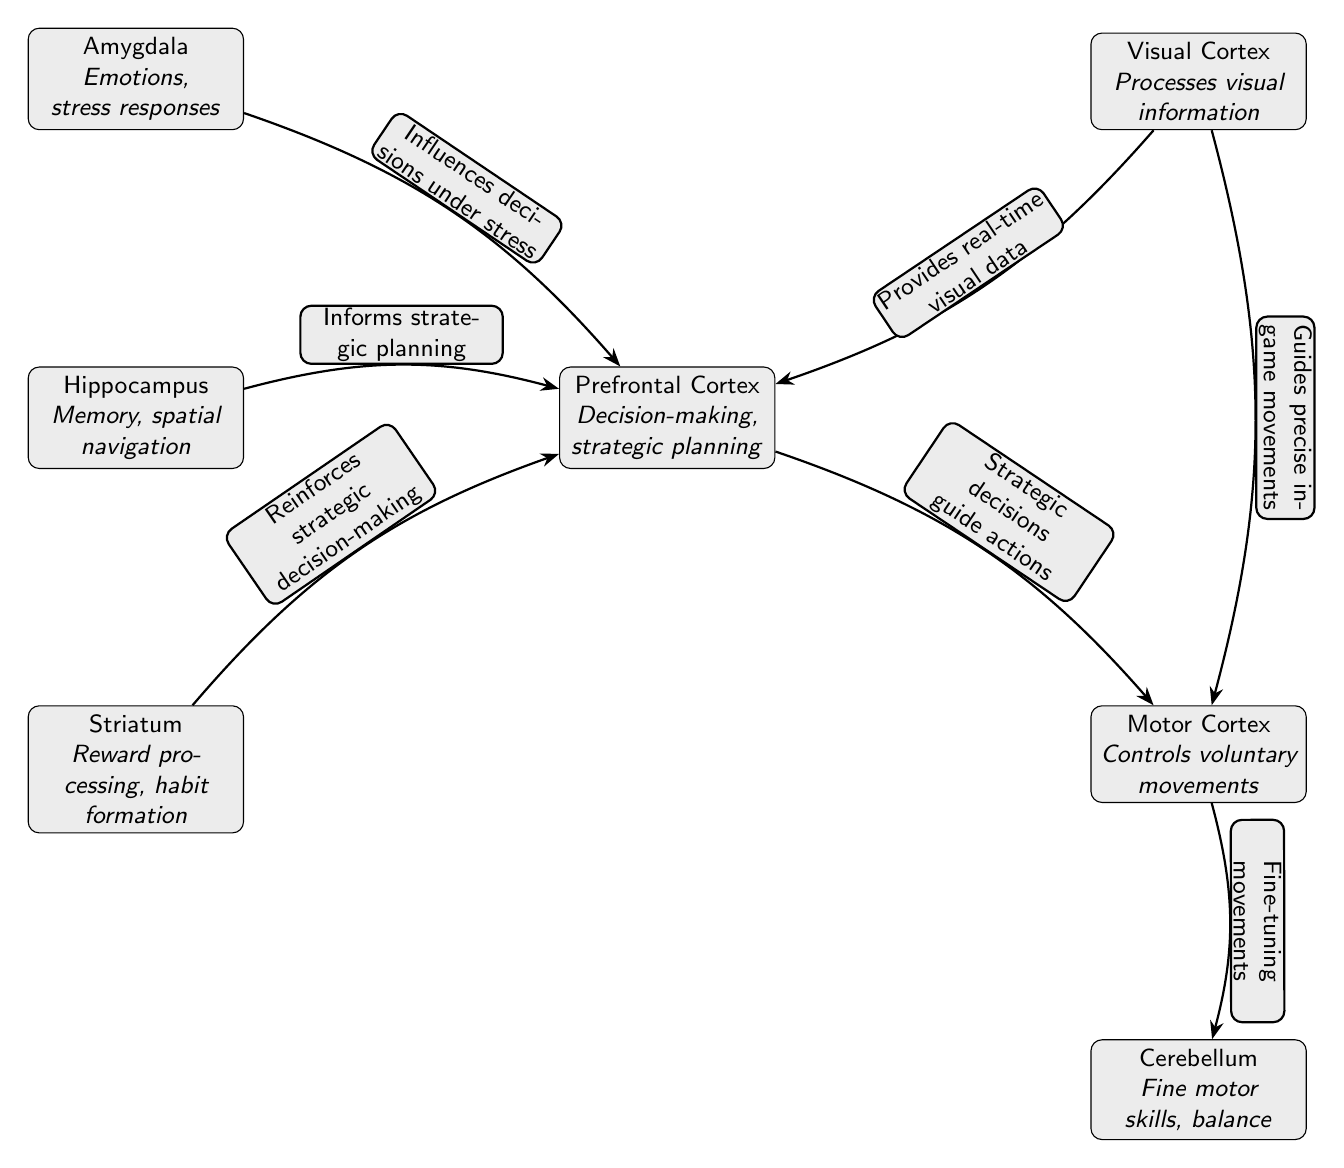What area is responsible for decision-making during gaming? The diagram shows that the Prefrontal Cortex is linked to decision-making and strategic planning functions, making it responsible for these activities in gaming sessions.
Answer: Prefrontal Cortex How many main areas are involved in this diagram? By counting the nodes represented in the diagram, we can identify seven distinct areas that are involved in high-intensity gaming sessions.
Answer: 7 Which node influences decisions under stress? The diagram indicates that the Amygdala has a direct connection to the Prefrontal Cortex, influencing decision-making especially under stressful conditions, thus revealing its specific role.
Answer: Amygdala What type of information does the Visual Cortex provide? The diagram explicitly states that the Visual Cortex provides real-time visual data to the Prefrontal Cortex, indicating its importance for quick information processing in gaming.
Answer: Real-time visual data Which area reinforces strategic decision-making? The connection illustrated in the diagram shows that the Striatum reinforces the strategic decision-making processes carried out by the Prefrontal Cortex, establishing a feedback loop that enhances gaming performance.
Answer: Striatum What is the role of the Cerebellum in high-intensity gaming? The diagram describes the Cerebellum as responsible for fine motor skills and balance, which are critical for executing precise actions in gaming scenarios.
Answer: Fine motor skills, balance How do strategic decisions guide gaming actions? The diagram shows a directed edge from the Prefrontal Cortex to the Motor Cortex, labeled as "Strategic decisions guide actions." This indicates that strategic planning directly influences action execution.
Answer: Strategic decisions guide actions What two areas are connected by "provides real-time visual data"? The diagram clearly indicates that there is a connection from the Visual Cortex to the Prefrontal Cortex with the label "Provides real-time visual data," highlighting an important data flow in gaming.
Answer: Visual Cortex, Prefrontal Cortex Which structure informs strategic planning in the Prefrontal Cortex? Based on the diagram, the Hippocampus is shown to inform the strategic planning process in the Prefrontal Cortex, indicating its significant supporting role during gaming tasks.
Answer: Hippocampus 